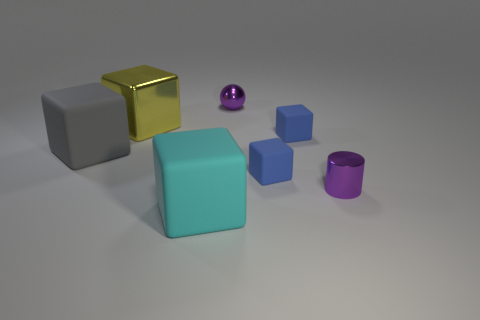Subtract 1 cubes. How many cubes are left? 4 Subtract all purple cubes. Subtract all yellow balls. How many cubes are left? 5 Add 3 large gray cubes. How many objects exist? 10 Subtract all balls. How many objects are left? 6 Add 1 large cyan matte things. How many large cyan matte things exist? 2 Subtract 0 brown blocks. How many objects are left? 7 Subtract all rubber objects. Subtract all tiny blue things. How many objects are left? 1 Add 6 large yellow cubes. How many large yellow cubes are left? 7 